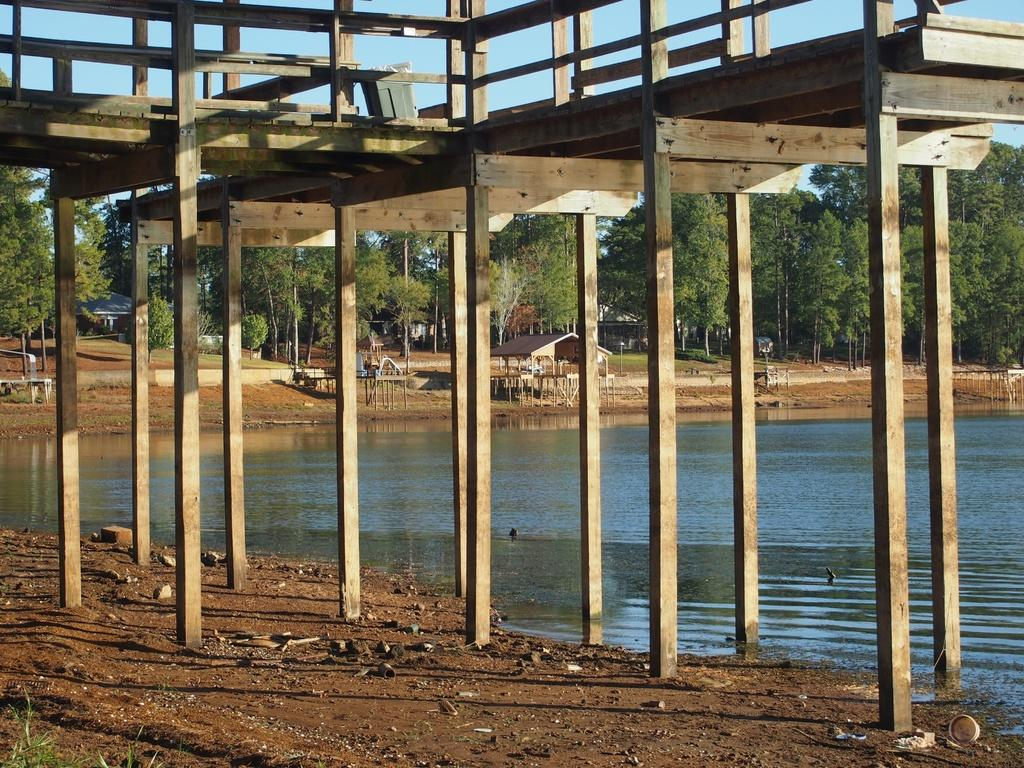What type of natural feature is present in the image? There is a lake in the image. What kind of structure can be seen in the image? There is a structure made of wood in the image. What are the tall, thin objects in the image? There are poles in the image. What type of vegetation is present in the image? There are trees in the image. What else can be found on the floor in the image? There are other objects on the floor in the image. What type of fiction is being offered by the train in the image? There is no train present in the image, so there is no fiction being offered. 